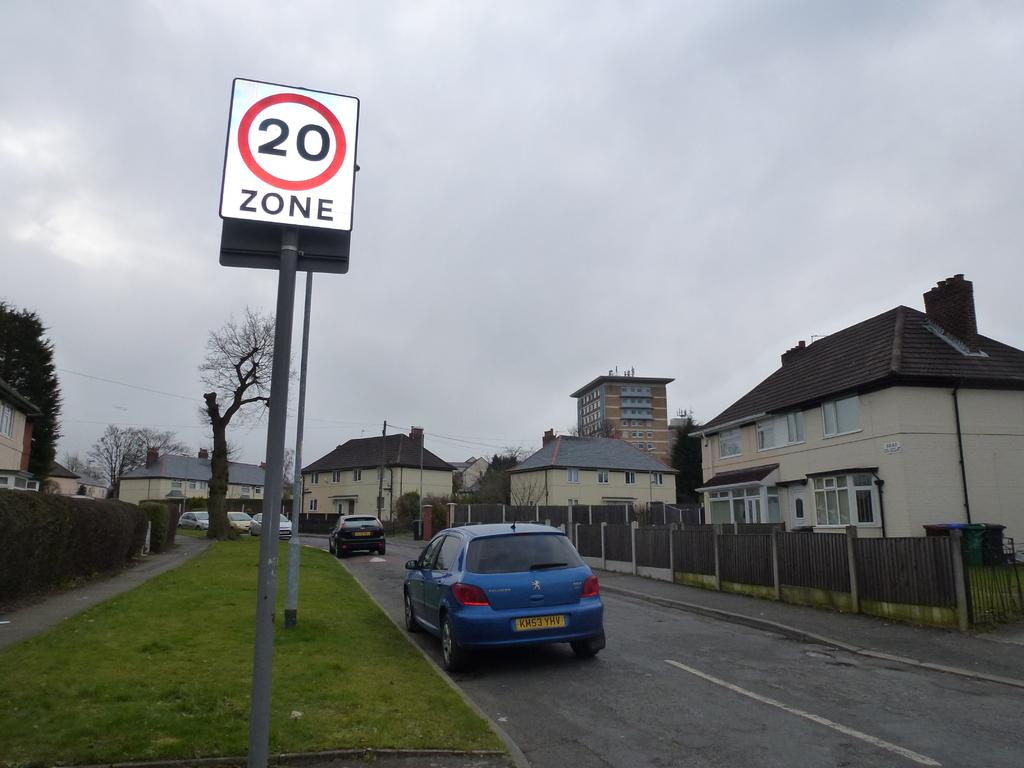<image>
Relay a brief, clear account of the picture shown. A blue car is driving in a residential area by a sign that says 20 Zone. 